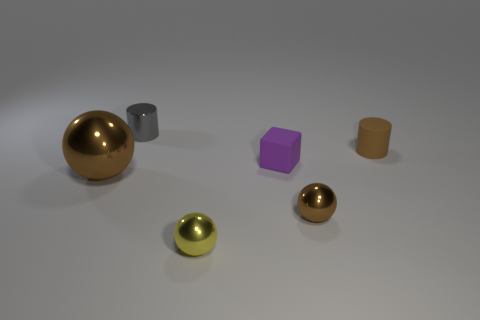There is a cylinder that is in front of the gray metallic cylinder; what material is it?
Ensure brevity in your answer.  Rubber. There is a tiny metal thing that is the same color as the big object; what is its shape?
Give a very brief answer. Sphere. Is there another thing that has the same material as the large brown thing?
Your answer should be compact. Yes. How big is the rubber cylinder?
Your response must be concise. Small. How many cyan objects are either metallic cylinders or small metallic spheres?
Your answer should be compact. 0. What number of brown objects have the same shape as the gray shiny thing?
Give a very brief answer. 1. How many other objects are the same size as the purple rubber thing?
Provide a succinct answer. 4. There is a large thing that is the same shape as the tiny yellow thing; what is its material?
Your answer should be very brief. Metal. What color is the rubber object in front of the brown matte cylinder?
Ensure brevity in your answer.  Purple. Is the number of big brown shiny objects to the right of the small gray object greater than the number of cyan metallic spheres?
Your response must be concise. No. 